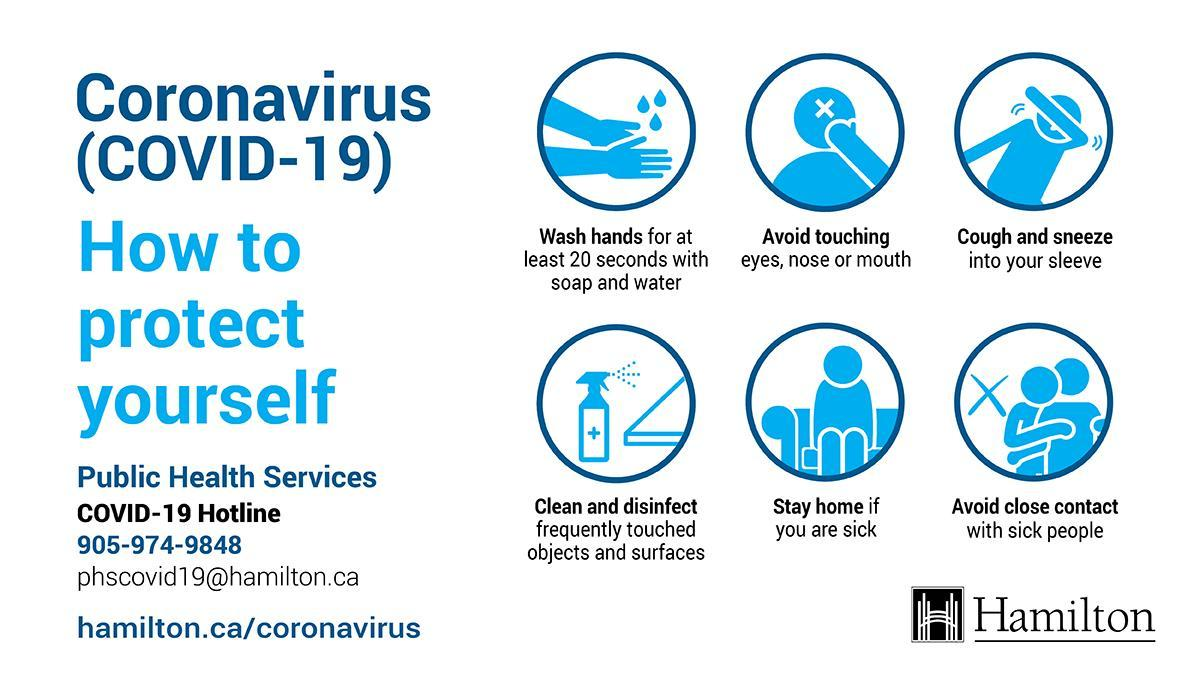How long one should wash their hands in order to prevent the spread of COVID-19?
Answer the question with a short phrase. atleast 20 seconds 